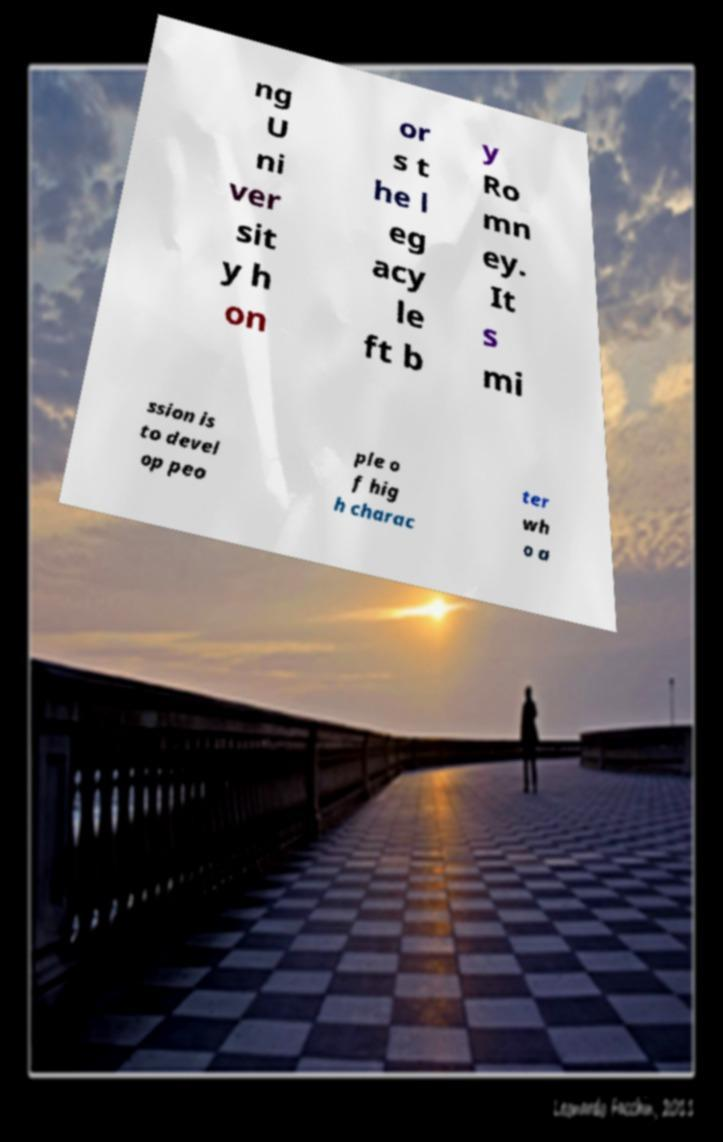There's text embedded in this image that I need extracted. Can you transcribe it verbatim? ng U ni ver sit y h on or s t he l eg acy le ft b y Ro mn ey. It s mi ssion is to devel op peo ple o f hig h charac ter wh o a 